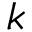<formula> <loc_0><loc_0><loc_500><loc_500>k</formula> 